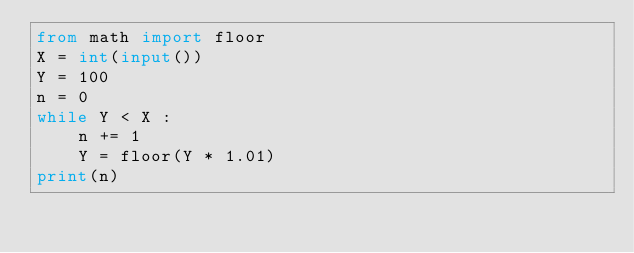Convert code to text. <code><loc_0><loc_0><loc_500><loc_500><_Python_>from math import floor
X = int(input())
Y = 100
n = 0
while Y < X :
    n += 1
    Y = floor(Y * 1.01)
print(n)</code> 